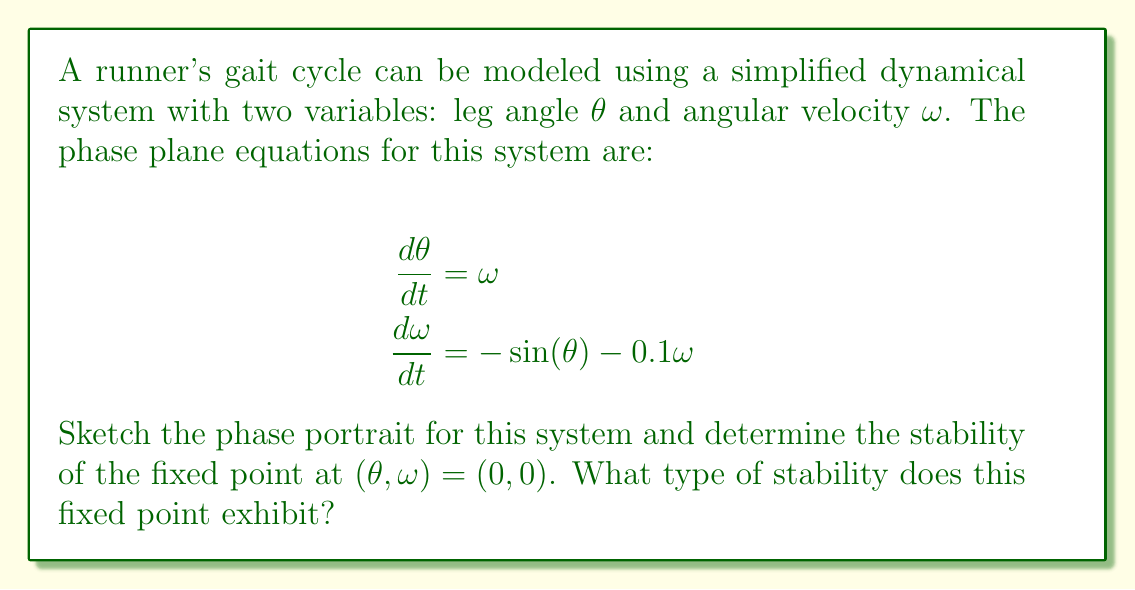Can you answer this question? To analyze the stability of the runner's gait cycle, we'll follow these steps:

1) First, identify the fixed points of the system by setting $\frac{d\theta}{dt}$ and $\frac{d\omega}{dt}$ to zero:

   $\omega = 0$
   $-\sin(\theta) - 0.1\omega = 0$

   This gives us the fixed point $(\theta, \omega) = (0, 0)$.

2) To determine the stability, we need to linearize the system around this fixed point. We calculate the Jacobian matrix:

   $$J = \begin{bmatrix}
   \frac{\partial}{\partial\theta}(\omega) & \frac{\partial}{\partial\omega}(\omega) \\
   \frac{\partial}{\partial\theta}(-\sin(\theta) - 0.1\omega) & \frac{\partial}{\partial\omega}(-\sin(\theta) - 0.1\omega)
   \end{bmatrix}$$

   $$J = \begin{bmatrix}
   0 & 1 \\
   -\cos(\theta) & -0.1
   \end{bmatrix}$$

3) Evaluate the Jacobian at the fixed point $(0, 0)$:

   $$J_{(0,0)} = \begin{bmatrix}
   0 & 1 \\
   -1 & -0.1
   \end{bmatrix}$$

4) Calculate the eigenvalues of $J_{(0,0)}$:

   $\det(J_{(0,0)} - \lambda I) = 0$

   $$\begin{vmatrix}
   -\lambda & 1 \\
   -1 & -0.1-\lambda
   \end{vmatrix} = 0$$

   $\lambda^2 + 0.1\lambda + 1 = 0$

   Solving this quadratic equation gives:
   $\lambda = -0.05 \pm 0.9987i$

5) Since the real parts of both eigenvalues are negative, the fixed point is stable. The presence of imaginary parts indicates that trajectories will spiral towards the fixed point.

6) To sketch the phase portrait:

[asy]
import graph;
size(200);
real f(real x, real y) { return y; }
real g(real x, real y) { return -sin(x) - 0.1*y; }
add(vectorfield(f, g, (-3,-3), (3,3), 0.3));
dot((0,0));
label("(0,0)", (0,0), SE);
[/asy]

The phase portrait shows trajectories spiraling towards the origin, confirming our stability analysis.
Answer: Stable spiral point 